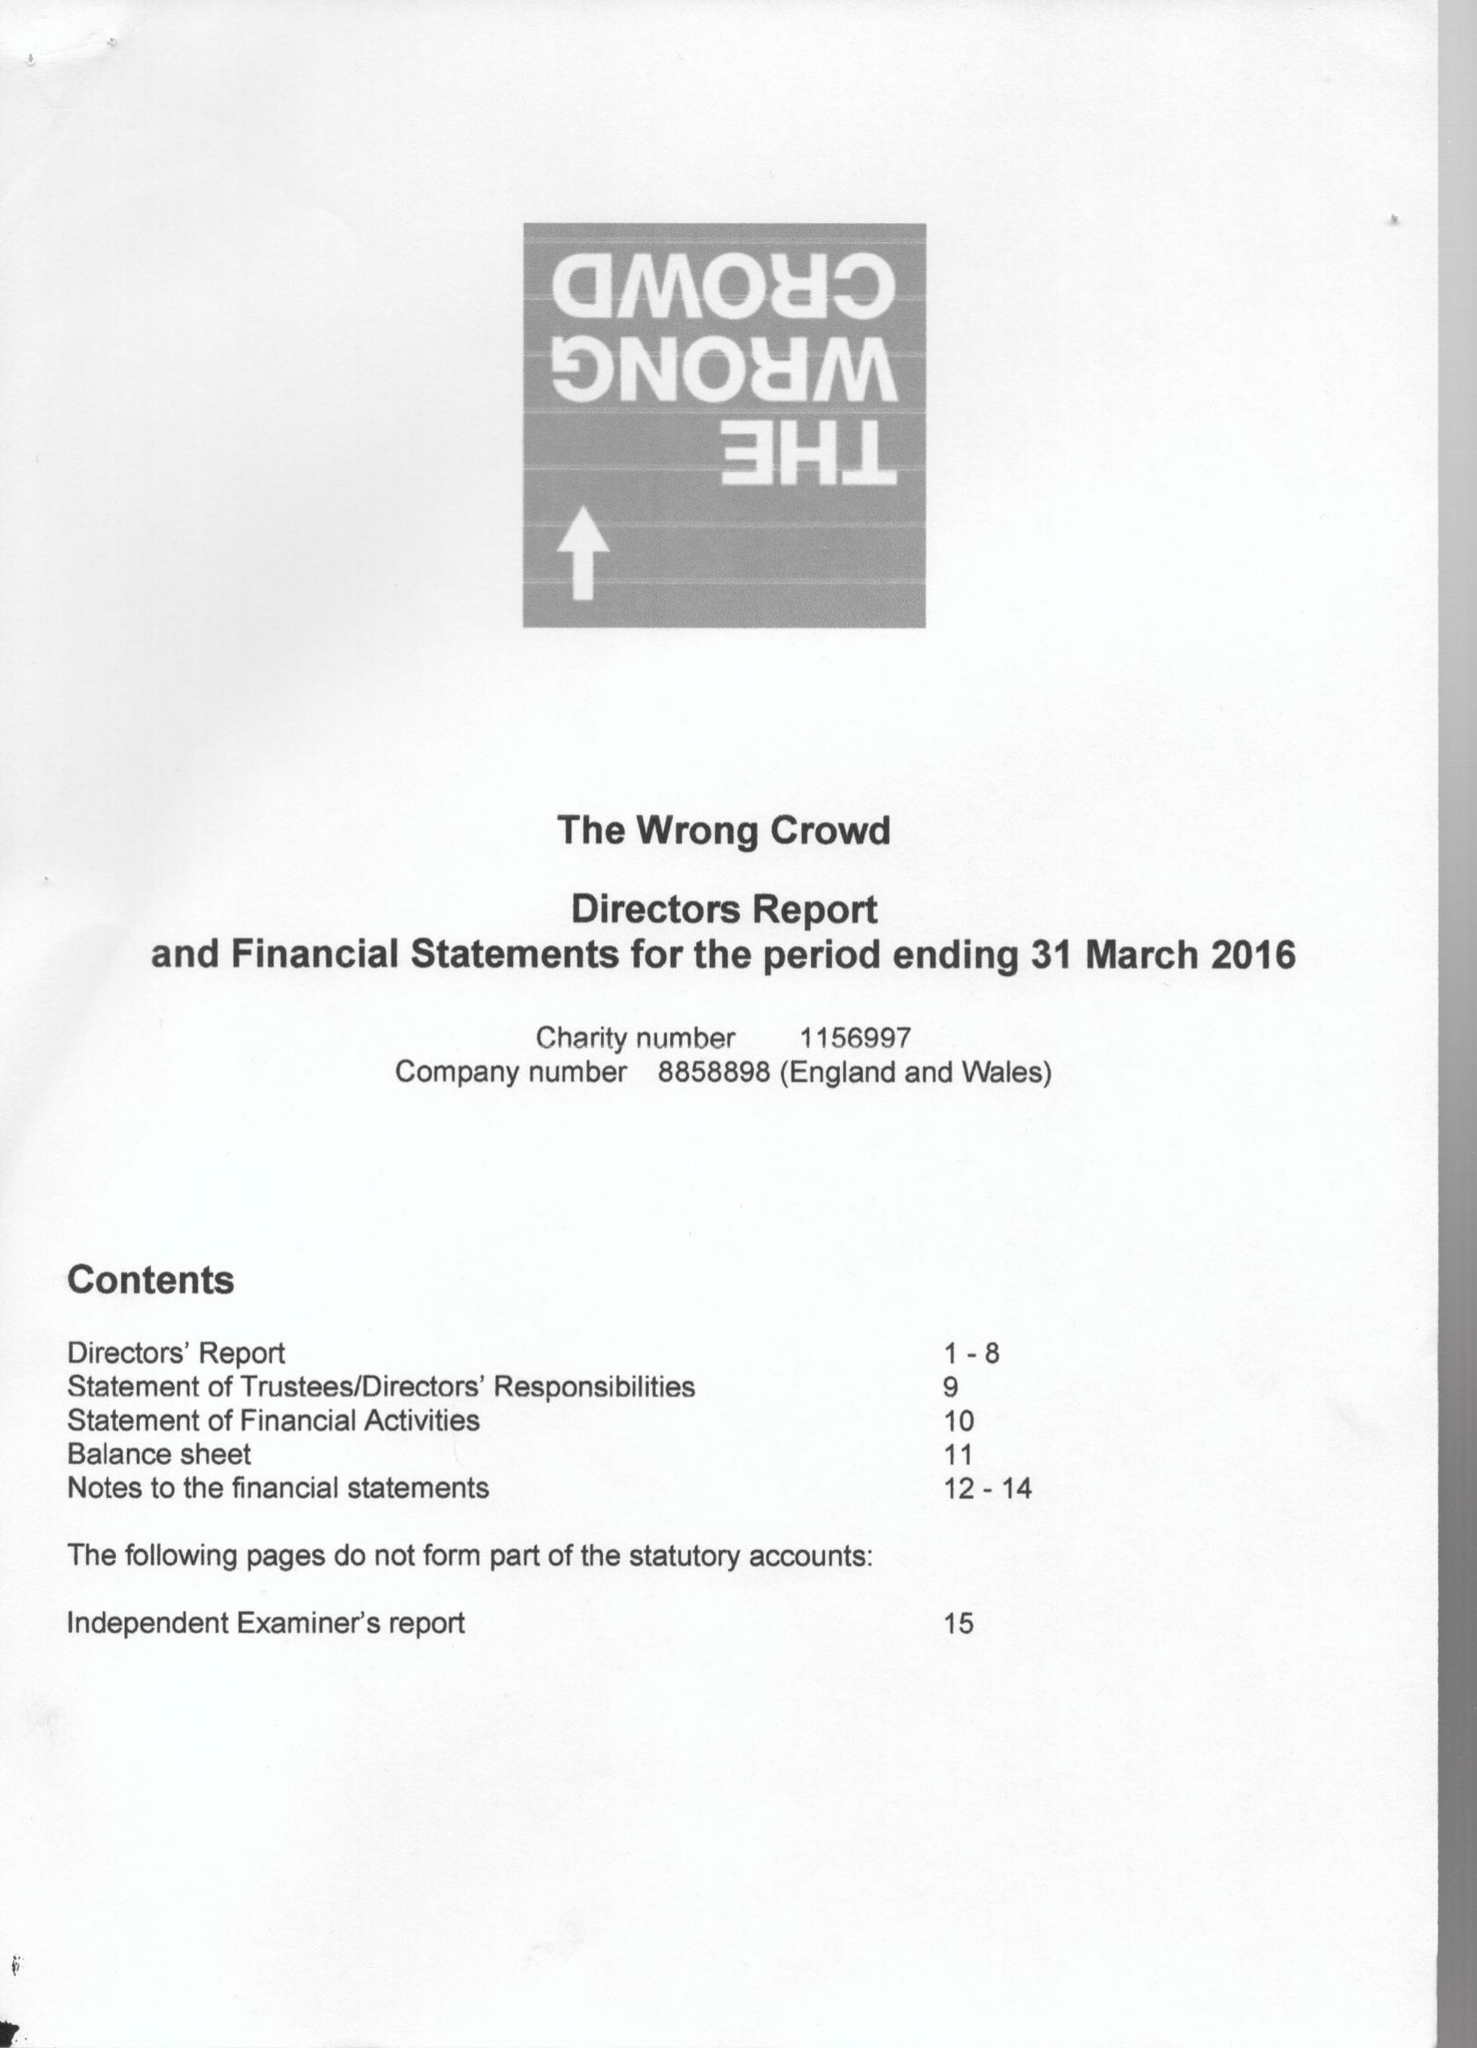What is the value for the address__street_line?
Answer the question using a single word or phrase. None 